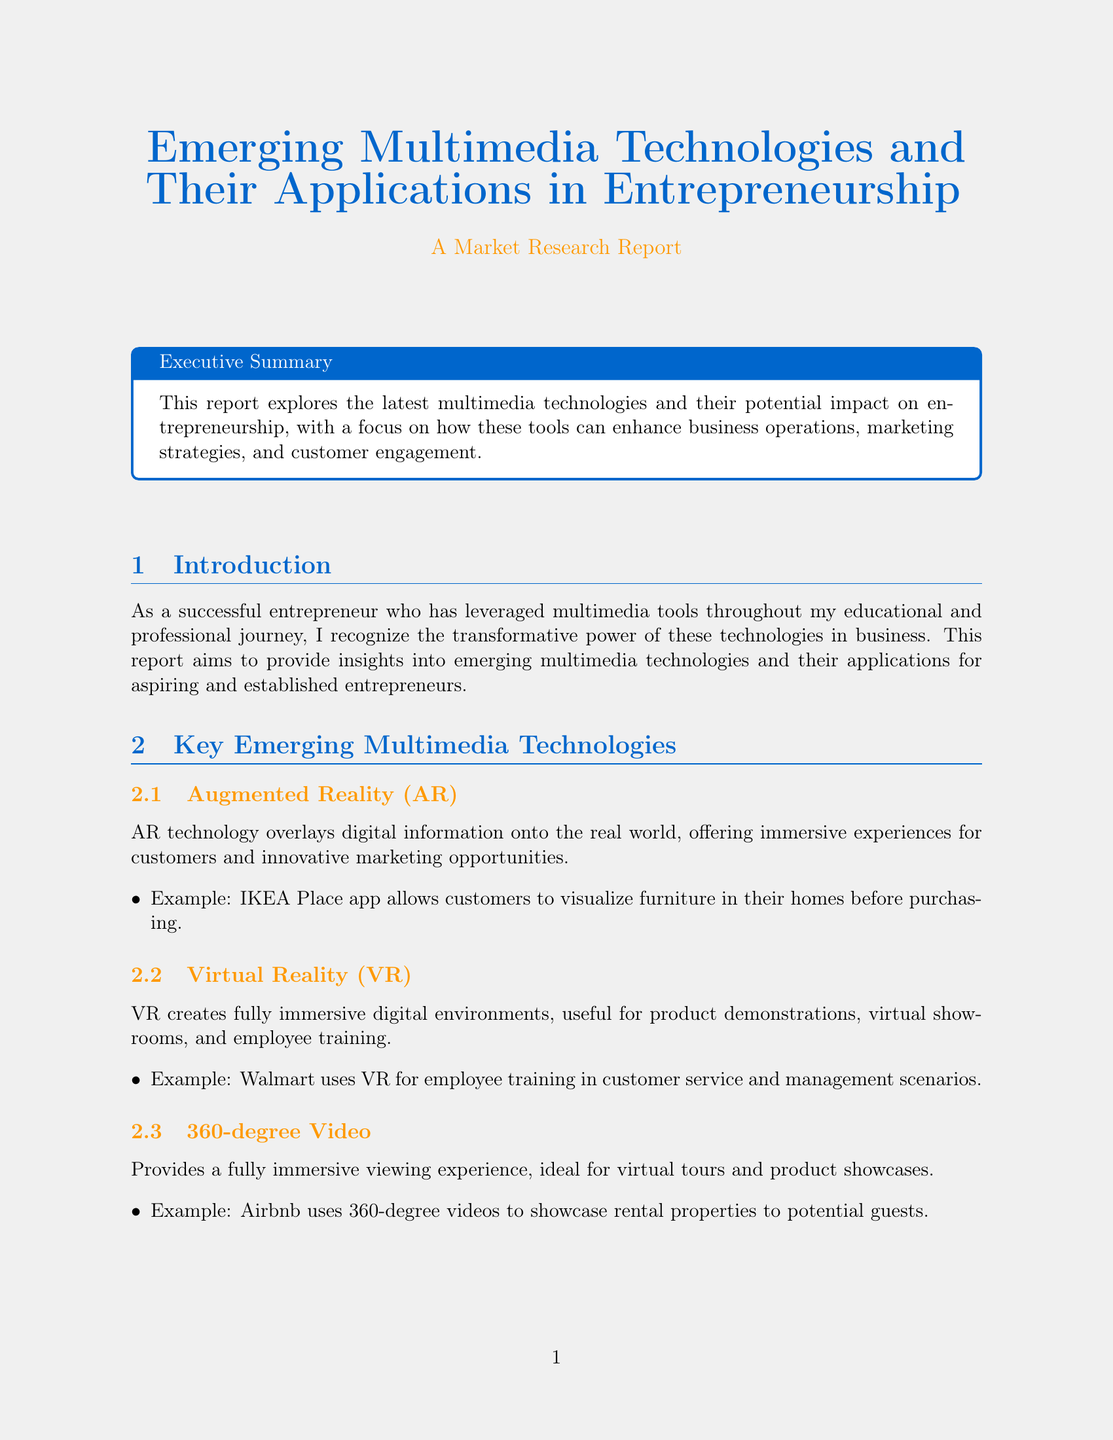What is the primary focus of the report? The primary focus of the report is on the impact of multimedia technologies on entrepreneurship, specifically enhancing business operations, marketing strategies, and customer engagement.
Answer: Enhancing business operations, marketing strategies, and customer engagement What is the expected CAGR for the augmented reality market from 2021 to 2028? The report states that the augmented reality market is expected to grow at a compound annual growth rate of 43.8% from 2021 to 2028.
Answer: 43.8% Name one application of Virtual Reality in employee training mentioned in the document. Walmart uses VR for employee training in customer service and management scenarios.
Answer: Walmart What technology did IKEA implement for visualizing furniture? The IKEA Place app allows customers to visualize furniture in their homes before purchasing.
Answer: IKEA Place app Which industry is mentioned as using VR for vehicle design and testing? The automotive industry, specifically mentioning companies like Ford, uses VR for vehicle design and testing.
Answer: Automotive What significant challenge related to multimedia technologies is highlighted in the report? One significant challenge mentioned is the high cost of developing high-quality VR and AR experiences, which can limit access for small businesses.
Answer: Cost What recent technological advancement is expected to enhance multimedia delivery? The rise of 5G networks is expected to enhance the delivery of high-quality multimedia experiences.
Answer: 5G networks Who is the CEO of Meta quoted in the report? The report quotes Mark Zuckerberg, CEO of Meta.
Answer: Mark Zuckerberg What multimedia technology is used for engaging marketing campaigns? Interactive video and augmented reality are used for creating engaging marketing campaigns.
Answer: Interactive video and AR 